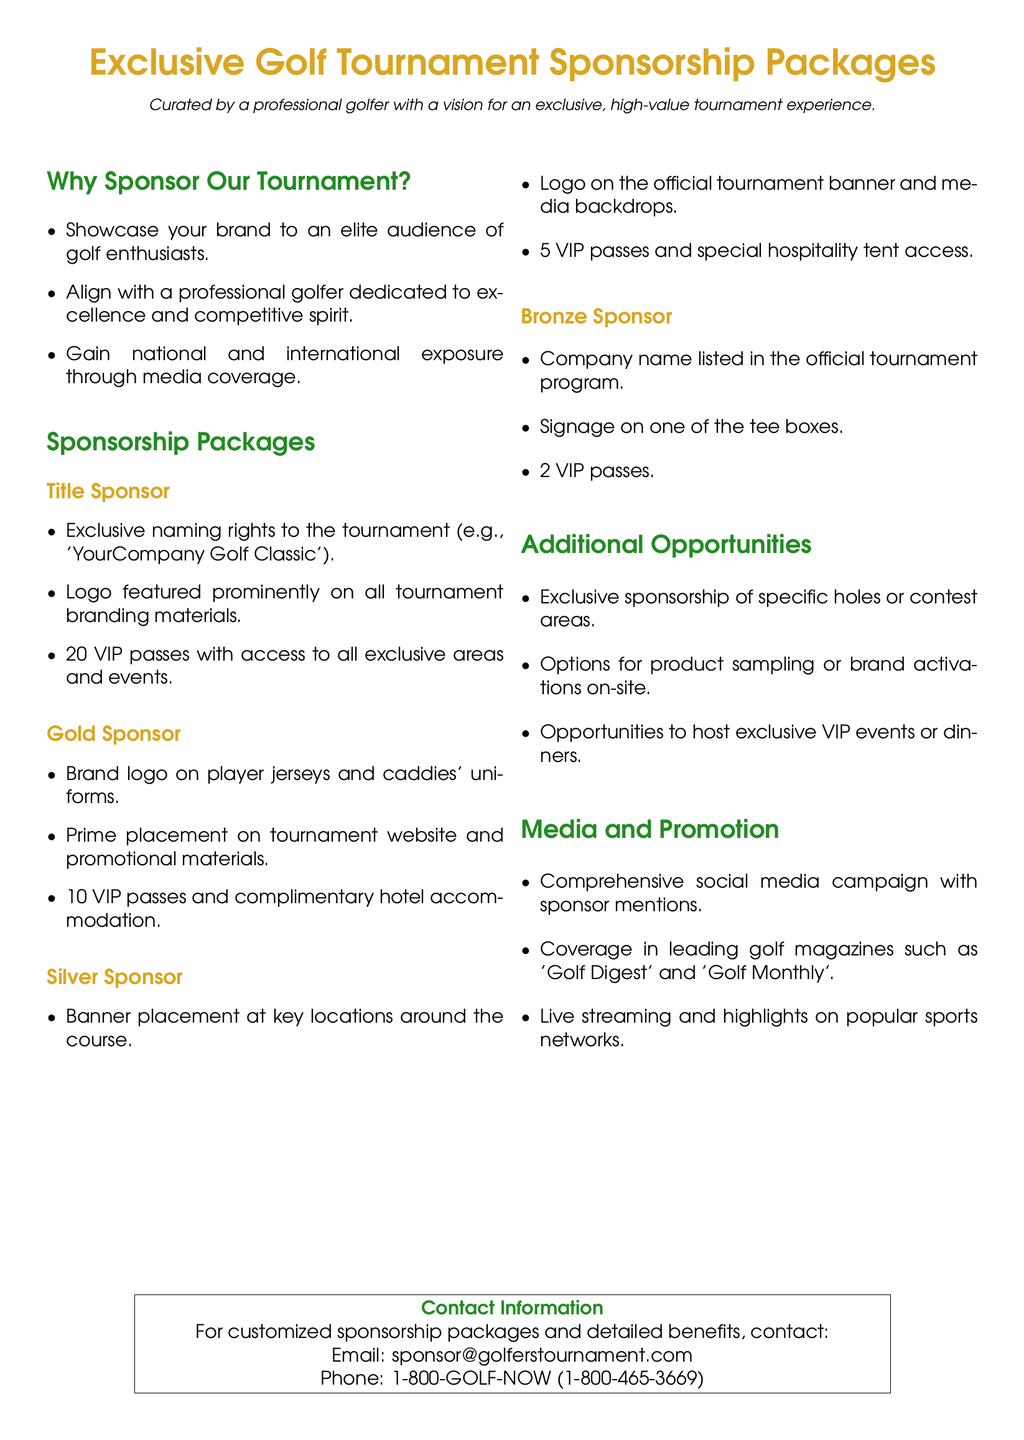What is the title of the tournament? The title sponsor has exclusive naming rights to the tournament which could be e.g., 'YourCompany Golf Classic'.
Answer: YourCompany Golf Classic How many VIP passes does the Title Sponsor receive? The Title Sponsor package includes 20 VIP passes with access to all exclusive areas and events.
Answer: 20 What is included in the Gold Sponsor package? The Gold Sponsor package includes brand logo on player jerseys, prime placement on the tournament website, and 10 VIP passes.
Answer: Brand logo on player jerseys, prime placement on website, 10 VIP passes Which golf magazines will cover the event? Leading golf magazines mentioned in the document include 'Golf Digest' and 'Golf Monthly'.
Answer: Golf Digest, Golf Monthly What opportunity is available for hole sponsorship? The document mentions exclusive sponsorship of specific holes or contest areas as an additional opportunity.
Answer: Specific holes How many VIP passes does the Silver Sponsor receive? The Silver Sponsor package includes 5 VIP passes and special hospitality tent access.
Answer: 5 What type of signage is included in the Bronze Sponsor package? The Bronze Sponsor receives signage on one of the tee boxes.
Answer: Signage on one of the tee boxes What is the contact email for sponsorship inquiries? The document provides a specific email address for sponsorship inquiries: sponsor@golferstournament.com.
Answer: sponsor@golferstournament.com How many VIP passes does the Bronze Sponsor receive? The Bronze Sponsor package includes 2 VIP passes.
Answer: 2 